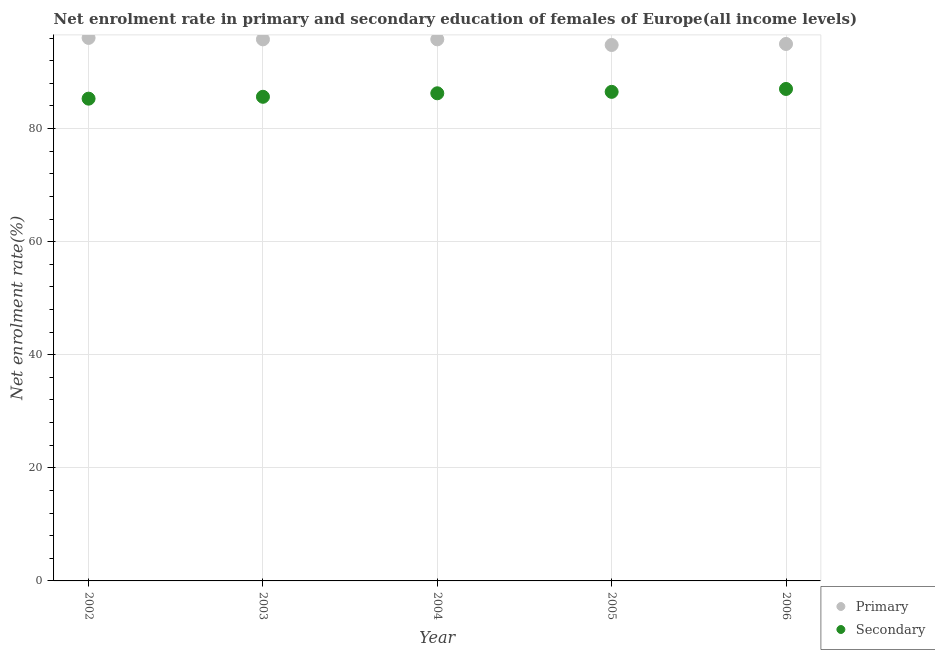How many different coloured dotlines are there?
Provide a short and direct response. 2. What is the enrollment rate in primary education in 2002?
Offer a very short reply. 96.03. Across all years, what is the maximum enrollment rate in secondary education?
Your answer should be compact. 87. Across all years, what is the minimum enrollment rate in secondary education?
Ensure brevity in your answer.  85.29. What is the total enrollment rate in primary education in the graph?
Make the answer very short. 477.31. What is the difference between the enrollment rate in primary education in 2002 and that in 2004?
Your answer should be very brief. 0.25. What is the difference between the enrollment rate in secondary education in 2006 and the enrollment rate in primary education in 2005?
Provide a short and direct response. -7.77. What is the average enrollment rate in primary education per year?
Provide a succinct answer. 95.46. In the year 2003, what is the difference between the enrollment rate in secondary education and enrollment rate in primary education?
Offer a very short reply. -10.16. In how many years, is the enrollment rate in secondary education greater than 32 %?
Offer a terse response. 5. What is the ratio of the enrollment rate in secondary education in 2002 to that in 2004?
Your answer should be compact. 0.99. Is the difference between the enrollment rate in primary education in 2002 and 2004 greater than the difference between the enrollment rate in secondary education in 2002 and 2004?
Provide a short and direct response. Yes. What is the difference between the highest and the second highest enrollment rate in secondary education?
Make the answer very short. 0.51. What is the difference between the highest and the lowest enrollment rate in primary education?
Provide a short and direct response. 1.25. In how many years, is the enrollment rate in secondary education greater than the average enrollment rate in secondary education taken over all years?
Offer a very short reply. 3. Is the sum of the enrollment rate in primary education in 2002 and 2004 greater than the maximum enrollment rate in secondary education across all years?
Make the answer very short. Yes. Does the enrollment rate in primary education monotonically increase over the years?
Provide a short and direct response. No. Is the enrollment rate in primary education strictly greater than the enrollment rate in secondary education over the years?
Make the answer very short. Yes. Is the enrollment rate in primary education strictly less than the enrollment rate in secondary education over the years?
Keep it short and to the point. No. How many years are there in the graph?
Your response must be concise. 5. What is the difference between two consecutive major ticks on the Y-axis?
Your answer should be compact. 20. Are the values on the major ticks of Y-axis written in scientific E-notation?
Your answer should be very brief. No. Does the graph contain grids?
Offer a very short reply. Yes. How are the legend labels stacked?
Give a very brief answer. Vertical. What is the title of the graph?
Keep it short and to the point. Net enrolment rate in primary and secondary education of females of Europe(all income levels). What is the label or title of the X-axis?
Make the answer very short. Year. What is the label or title of the Y-axis?
Keep it short and to the point. Net enrolment rate(%). What is the Net enrolment rate(%) of Primary in 2002?
Give a very brief answer. 96.03. What is the Net enrolment rate(%) of Secondary in 2002?
Make the answer very short. 85.29. What is the Net enrolment rate(%) of Primary in 2003?
Your response must be concise. 95.77. What is the Net enrolment rate(%) of Secondary in 2003?
Keep it short and to the point. 85.62. What is the Net enrolment rate(%) of Primary in 2004?
Your response must be concise. 95.78. What is the Net enrolment rate(%) of Secondary in 2004?
Offer a very short reply. 86.24. What is the Net enrolment rate(%) of Primary in 2005?
Provide a short and direct response. 94.78. What is the Net enrolment rate(%) in Secondary in 2005?
Ensure brevity in your answer.  86.49. What is the Net enrolment rate(%) of Primary in 2006?
Your answer should be very brief. 94.96. What is the Net enrolment rate(%) of Secondary in 2006?
Make the answer very short. 87. Across all years, what is the maximum Net enrolment rate(%) of Primary?
Offer a very short reply. 96.03. Across all years, what is the maximum Net enrolment rate(%) of Secondary?
Your answer should be compact. 87. Across all years, what is the minimum Net enrolment rate(%) of Primary?
Provide a short and direct response. 94.78. Across all years, what is the minimum Net enrolment rate(%) of Secondary?
Your response must be concise. 85.29. What is the total Net enrolment rate(%) of Primary in the graph?
Ensure brevity in your answer.  477.31. What is the total Net enrolment rate(%) in Secondary in the graph?
Make the answer very short. 430.63. What is the difference between the Net enrolment rate(%) of Primary in 2002 and that in 2003?
Give a very brief answer. 0.26. What is the difference between the Net enrolment rate(%) of Secondary in 2002 and that in 2003?
Provide a short and direct response. -0.33. What is the difference between the Net enrolment rate(%) of Primary in 2002 and that in 2004?
Keep it short and to the point. 0.25. What is the difference between the Net enrolment rate(%) of Secondary in 2002 and that in 2004?
Offer a very short reply. -0.95. What is the difference between the Net enrolment rate(%) in Primary in 2002 and that in 2005?
Offer a very short reply. 1.25. What is the difference between the Net enrolment rate(%) of Secondary in 2002 and that in 2005?
Ensure brevity in your answer.  -1.2. What is the difference between the Net enrolment rate(%) of Primary in 2002 and that in 2006?
Your answer should be very brief. 1.07. What is the difference between the Net enrolment rate(%) of Secondary in 2002 and that in 2006?
Offer a very short reply. -1.72. What is the difference between the Net enrolment rate(%) in Primary in 2003 and that in 2004?
Keep it short and to the point. -0. What is the difference between the Net enrolment rate(%) in Secondary in 2003 and that in 2004?
Offer a terse response. -0.62. What is the difference between the Net enrolment rate(%) of Primary in 2003 and that in 2005?
Make the answer very short. 1. What is the difference between the Net enrolment rate(%) in Secondary in 2003 and that in 2005?
Offer a very short reply. -0.87. What is the difference between the Net enrolment rate(%) of Primary in 2003 and that in 2006?
Your response must be concise. 0.81. What is the difference between the Net enrolment rate(%) of Secondary in 2003 and that in 2006?
Keep it short and to the point. -1.39. What is the difference between the Net enrolment rate(%) in Primary in 2004 and that in 2005?
Keep it short and to the point. 1. What is the difference between the Net enrolment rate(%) in Secondary in 2004 and that in 2005?
Your answer should be very brief. -0.25. What is the difference between the Net enrolment rate(%) in Primary in 2004 and that in 2006?
Offer a very short reply. 0.82. What is the difference between the Net enrolment rate(%) in Secondary in 2004 and that in 2006?
Your response must be concise. -0.77. What is the difference between the Net enrolment rate(%) in Primary in 2005 and that in 2006?
Provide a short and direct response. -0.18. What is the difference between the Net enrolment rate(%) in Secondary in 2005 and that in 2006?
Give a very brief answer. -0.51. What is the difference between the Net enrolment rate(%) in Primary in 2002 and the Net enrolment rate(%) in Secondary in 2003?
Provide a short and direct response. 10.41. What is the difference between the Net enrolment rate(%) in Primary in 2002 and the Net enrolment rate(%) in Secondary in 2004?
Ensure brevity in your answer.  9.79. What is the difference between the Net enrolment rate(%) of Primary in 2002 and the Net enrolment rate(%) of Secondary in 2005?
Provide a short and direct response. 9.54. What is the difference between the Net enrolment rate(%) of Primary in 2002 and the Net enrolment rate(%) of Secondary in 2006?
Provide a succinct answer. 9.03. What is the difference between the Net enrolment rate(%) of Primary in 2003 and the Net enrolment rate(%) of Secondary in 2004?
Ensure brevity in your answer.  9.54. What is the difference between the Net enrolment rate(%) in Primary in 2003 and the Net enrolment rate(%) in Secondary in 2005?
Your response must be concise. 9.28. What is the difference between the Net enrolment rate(%) in Primary in 2003 and the Net enrolment rate(%) in Secondary in 2006?
Give a very brief answer. 8.77. What is the difference between the Net enrolment rate(%) in Primary in 2004 and the Net enrolment rate(%) in Secondary in 2005?
Make the answer very short. 9.29. What is the difference between the Net enrolment rate(%) in Primary in 2004 and the Net enrolment rate(%) in Secondary in 2006?
Make the answer very short. 8.77. What is the difference between the Net enrolment rate(%) in Primary in 2005 and the Net enrolment rate(%) in Secondary in 2006?
Provide a succinct answer. 7.77. What is the average Net enrolment rate(%) in Primary per year?
Your answer should be very brief. 95.46. What is the average Net enrolment rate(%) in Secondary per year?
Give a very brief answer. 86.13. In the year 2002, what is the difference between the Net enrolment rate(%) in Primary and Net enrolment rate(%) in Secondary?
Your answer should be very brief. 10.74. In the year 2003, what is the difference between the Net enrolment rate(%) of Primary and Net enrolment rate(%) of Secondary?
Give a very brief answer. 10.16. In the year 2004, what is the difference between the Net enrolment rate(%) of Primary and Net enrolment rate(%) of Secondary?
Your response must be concise. 9.54. In the year 2005, what is the difference between the Net enrolment rate(%) in Primary and Net enrolment rate(%) in Secondary?
Your response must be concise. 8.29. In the year 2006, what is the difference between the Net enrolment rate(%) of Primary and Net enrolment rate(%) of Secondary?
Offer a very short reply. 7.95. What is the ratio of the Net enrolment rate(%) of Primary in 2002 to that in 2005?
Provide a succinct answer. 1.01. What is the ratio of the Net enrolment rate(%) in Secondary in 2002 to that in 2005?
Your answer should be very brief. 0.99. What is the ratio of the Net enrolment rate(%) in Primary in 2002 to that in 2006?
Ensure brevity in your answer.  1.01. What is the ratio of the Net enrolment rate(%) in Secondary in 2002 to that in 2006?
Give a very brief answer. 0.98. What is the ratio of the Net enrolment rate(%) in Primary in 2003 to that in 2005?
Provide a short and direct response. 1.01. What is the ratio of the Net enrolment rate(%) of Primary in 2003 to that in 2006?
Your answer should be compact. 1.01. What is the ratio of the Net enrolment rate(%) in Secondary in 2003 to that in 2006?
Provide a succinct answer. 0.98. What is the ratio of the Net enrolment rate(%) in Primary in 2004 to that in 2005?
Offer a very short reply. 1.01. What is the ratio of the Net enrolment rate(%) in Primary in 2004 to that in 2006?
Ensure brevity in your answer.  1.01. What is the ratio of the Net enrolment rate(%) in Secondary in 2004 to that in 2006?
Provide a short and direct response. 0.99. What is the ratio of the Net enrolment rate(%) in Primary in 2005 to that in 2006?
Make the answer very short. 1. What is the ratio of the Net enrolment rate(%) in Secondary in 2005 to that in 2006?
Provide a short and direct response. 0.99. What is the difference between the highest and the second highest Net enrolment rate(%) in Primary?
Your answer should be compact. 0.25. What is the difference between the highest and the second highest Net enrolment rate(%) of Secondary?
Offer a terse response. 0.51. What is the difference between the highest and the lowest Net enrolment rate(%) of Primary?
Provide a succinct answer. 1.25. What is the difference between the highest and the lowest Net enrolment rate(%) in Secondary?
Ensure brevity in your answer.  1.72. 